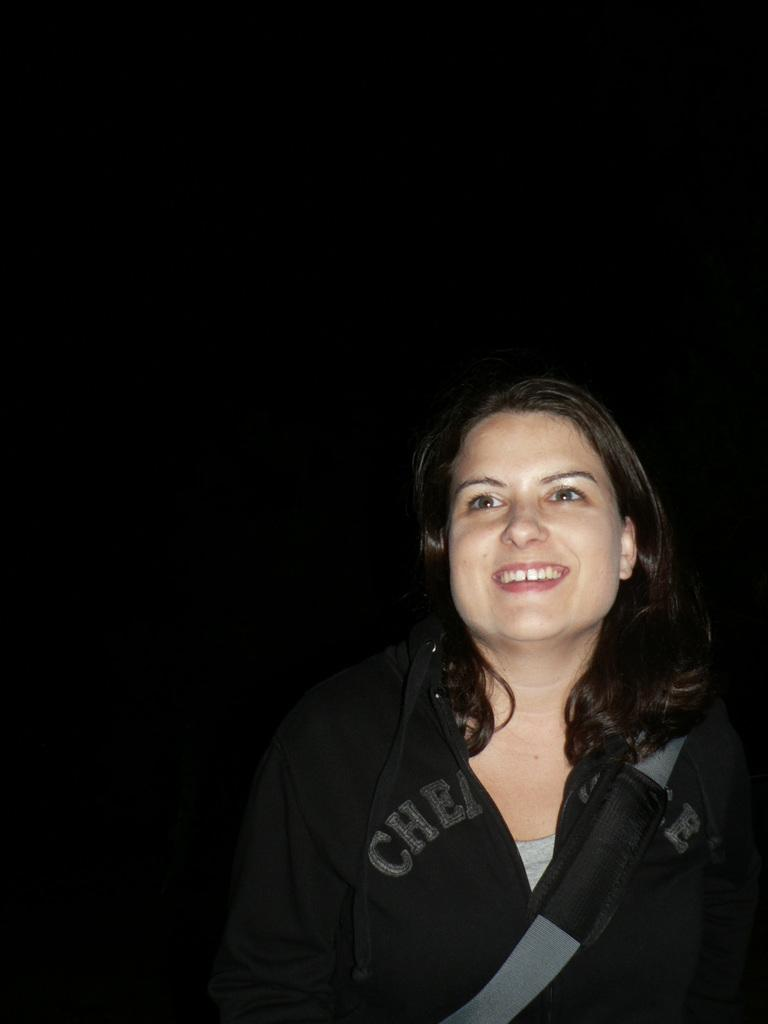Who is present in the image? There is a woman in the image. What is the woman's facial expression? The woman is smiling. What can be seen attached to the woman in the image? There is a strap visible in the image. How would you describe the background of the image? The background of the image has a dark view. Can you see any mountains in the background of the image? There are no mountains visible in the background of the image. What color is the woman's eye in the image? The provided facts do not mention the color of the woman's eye, so it cannot be determined from the image. 